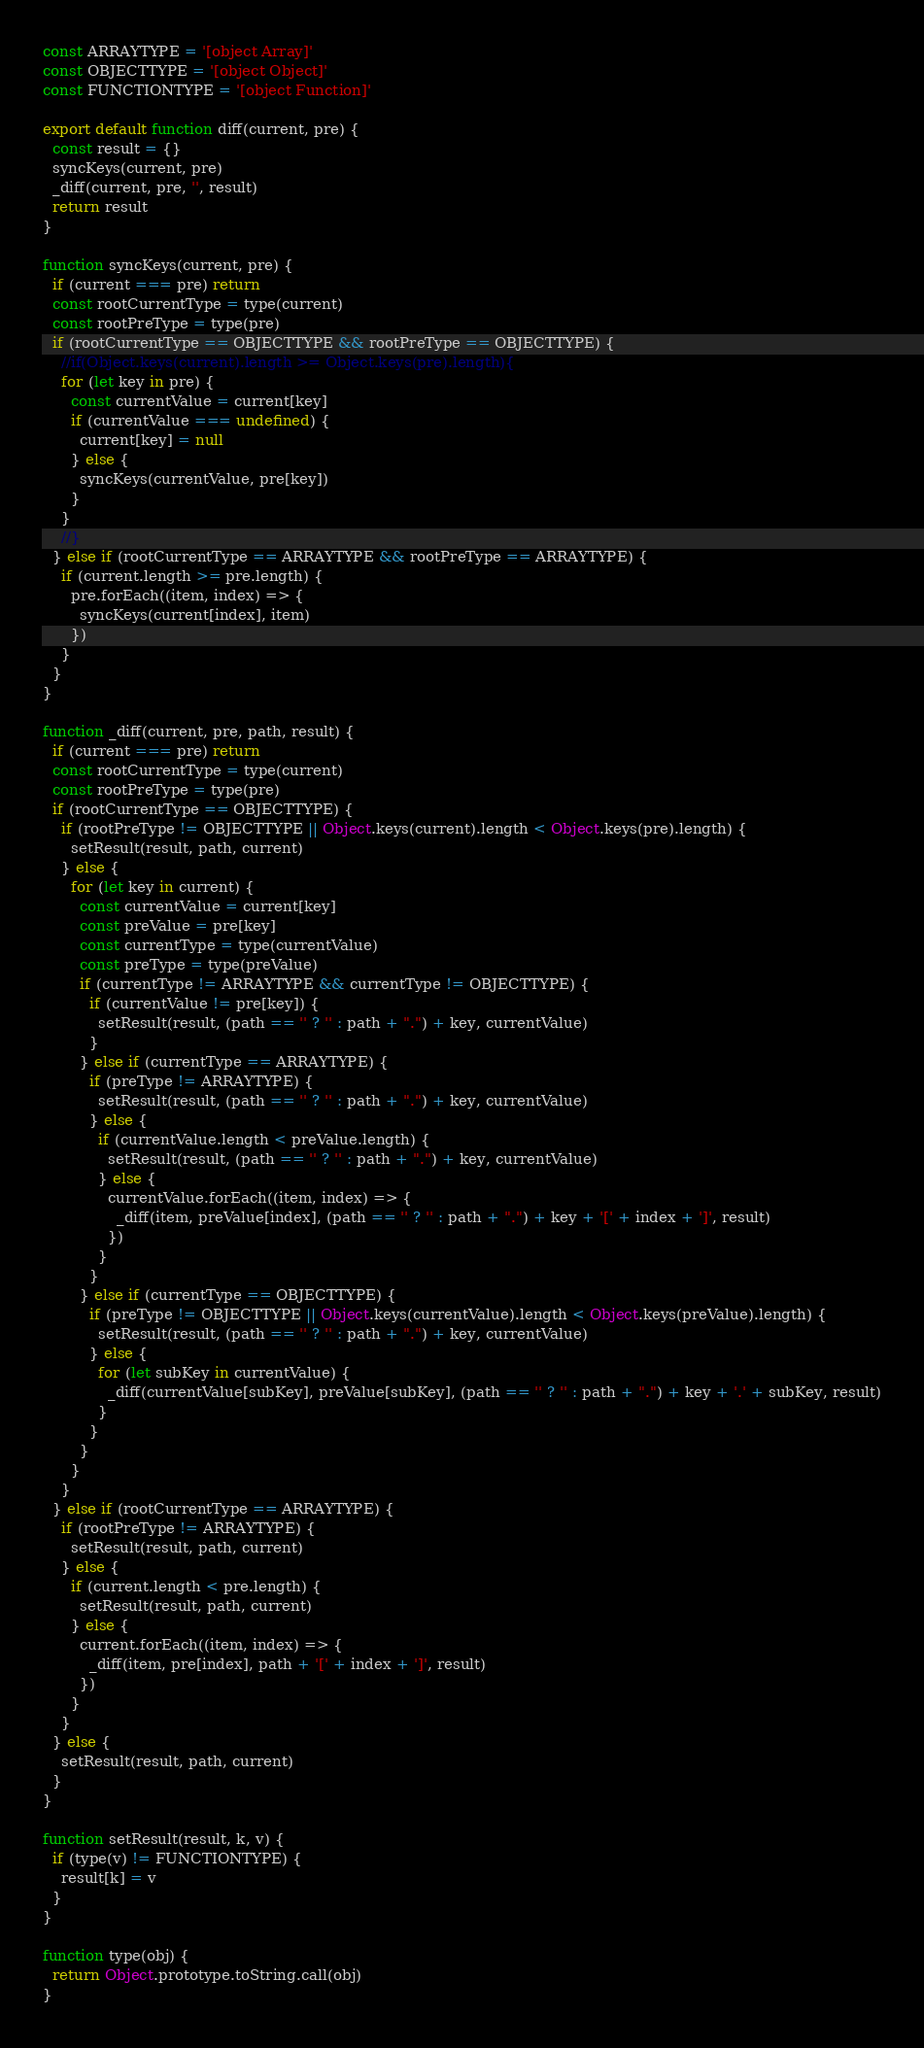Convert code to text. <code><loc_0><loc_0><loc_500><loc_500><_JavaScript_>const ARRAYTYPE = '[object Array]'
const OBJECTTYPE = '[object Object]'
const FUNCTIONTYPE = '[object Function]'

export default function diff(current, pre) {
  const result = {}
  syncKeys(current, pre)
  _diff(current, pre, '', result)
  return result
}

function syncKeys(current, pre) {
  if (current === pre) return
  const rootCurrentType = type(current)
  const rootPreType = type(pre)
  if (rootCurrentType == OBJECTTYPE && rootPreType == OBJECTTYPE) {
    //if(Object.keys(current).length >= Object.keys(pre).length){
    for (let key in pre) {
      const currentValue = current[key]
      if (currentValue === undefined) {
        current[key] = null
      } else {
        syncKeys(currentValue, pre[key])
      }
    }
    //}
  } else if (rootCurrentType == ARRAYTYPE && rootPreType == ARRAYTYPE) {
    if (current.length >= pre.length) {
      pre.forEach((item, index) => {
        syncKeys(current[index], item)
      })
    }
  }
}

function _diff(current, pre, path, result) {
  if (current === pre) return
  const rootCurrentType = type(current)
  const rootPreType = type(pre)
  if (rootCurrentType == OBJECTTYPE) {
    if (rootPreType != OBJECTTYPE || Object.keys(current).length < Object.keys(pre).length) {
      setResult(result, path, current)
    } else {
      for (let key in current) {
        const currentValue = current[key]
        const preValue = pre[key]
        const currentType = type(currentValue)
        const preType = type(preValue)
        if (currentType != ARRAYTYPE && currentType != OBJECTTYPE) {
          if (currentValue != pre[key]) {
            setResult(result, (path == '' ? '' : path + ".") + key, currentValue)
          }
        } else if (currentType == ARRAYTYPE) {
          if (preType != ARRAYTYPE) {
            setResult(result, (path == '' ? '' : path + ".") + key, currentValue)
          } else {
            if (currentValue.length < preValue.length) {
              setResult(result, (path == '' ? '' : path + ".") + key, currentValue)
            } else {
              currentValue.forEach((item, index) => {
                _diff(item, preValue[index], (path == '' ? '' : path + ".") + key + '[' + index + ']', result)
              })
            }
          }
        } else if (currentType == OBJECTTYPE) {
          if (preType != OBJECTTYPE || Object.keys(currentValue).length < Object.keys(preValue).length) {
            setResult(result, (path == '' ? '' : path + ".") + key, currentValue)
          } else {
            for (let subKey in currentValue) {
              _diff(currentValue[subKey], preValue[subKey], (path == '' ? '' : path + ".") + key + '.' + subKey, result)
            }
          }
        }
      }
    }
  } else if (rootCurrentType == ARRAYTYPE) {
    if (rootPreType != ARRAYTYPE) {
      setResult(result, path, current)
    } else {
      if (current.length < pre.length) {
        setResult(result, path, current)
      } else {
        current.forEach((item, index) => {
          _diff(item, pre[index], path + '[' + index + ']', result)
        })
      }
    }
  } else {
    setResult(result, path, current)
  }
}

function setResult(result, k, v) {
  if (type(v) != FUNCTIONTYPE) {
    result[k] = v
  }
}

function type(obj) {
  return Object.prototype.toString.call(obj)
}</code> 